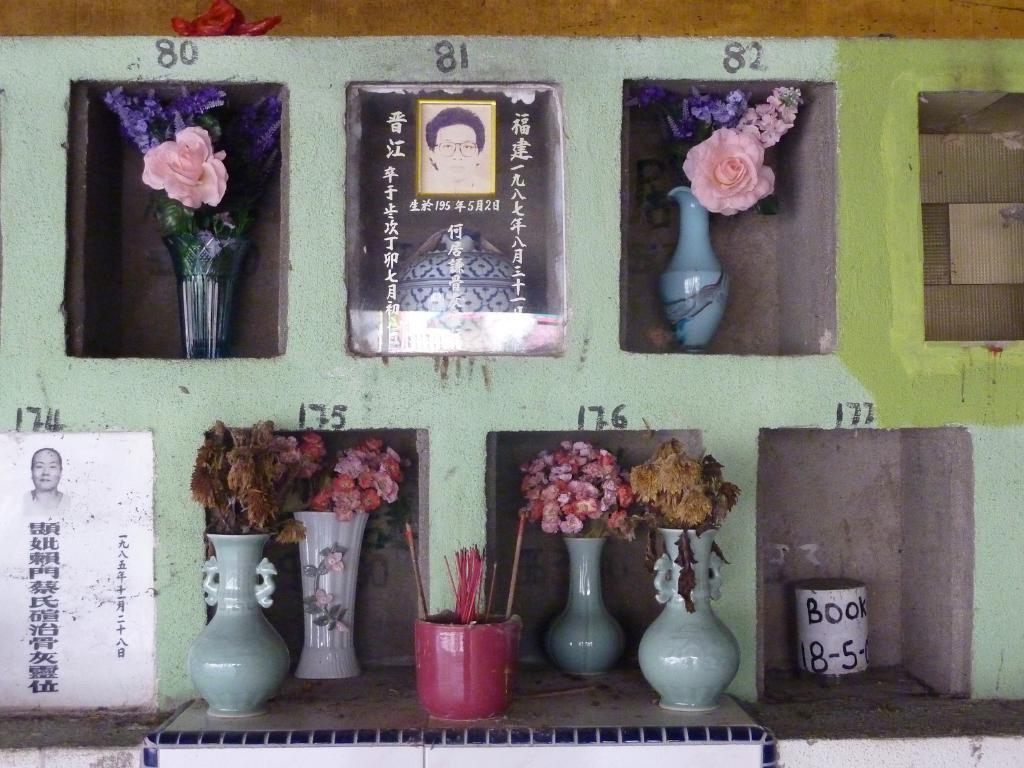Describe this image in one or two sentences. In this picture there are different flower vases and there are different flowers in the flowers vases and there is a photo of a person and there is a text and there are numbers on the wall. 